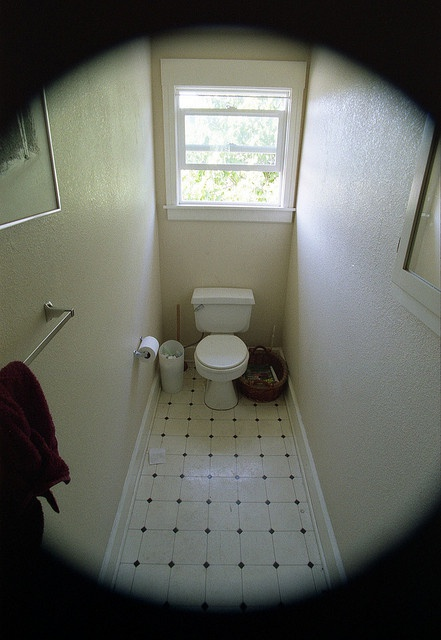Describe the objects in this image and their specific colors. I can see a toilet in black, gray, darkgray, and darkgreen tones in this image. 